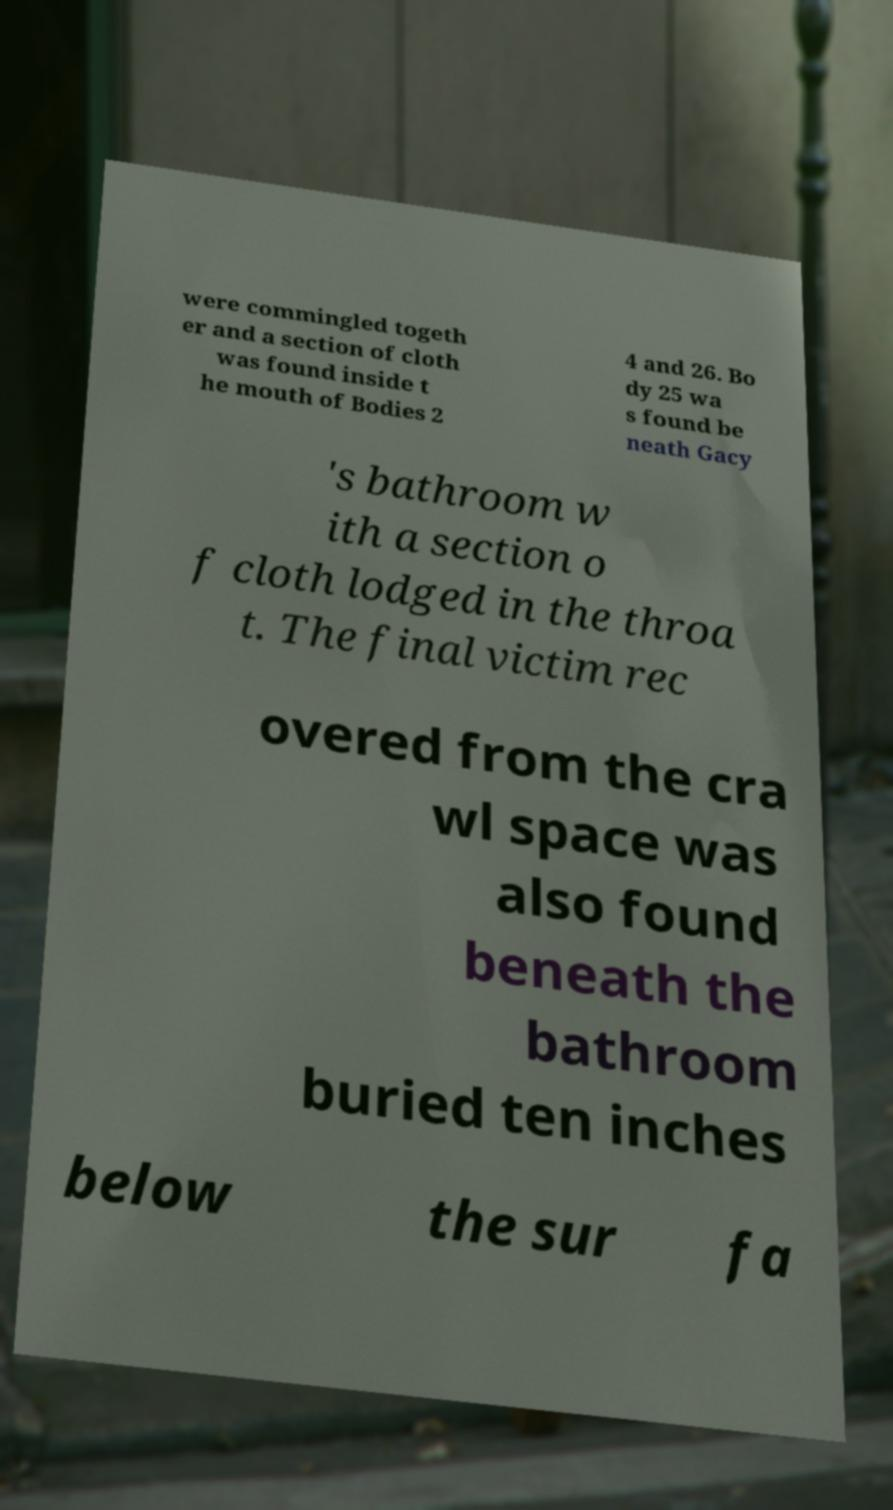Could you assist in decoding the text presented in this image and type it out clearly? were commingled togeth er and a section of cloth was found inside t he mouth of Bodies 2 4 and 26. Bo dy 25 wa s found be neath Gacy 's bathroom w ith a section o f cloth lodged in the throa t. The final victim rec overed from the cra wl space was also found beneath the bathroom buried ten inches below the sur fa 